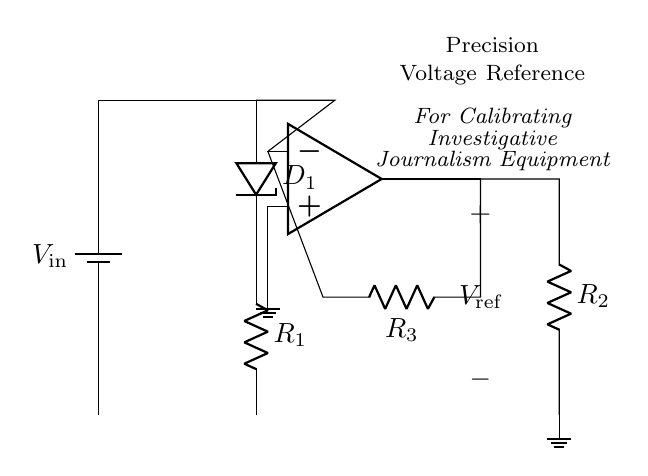What type of diode is used in this circuit? The circuit shows a Zener diode labeled as D1. Zener diodes are specifically used for voltage regulation.
Answer: Zener diode What is the value of the output voltage labeled as V_ref? The output voltage is the reference voltage defined in the circuit, typically determined by the configuration of the operational amplifier and the resistors. However, the circuit does not specify a numeric value for V_ref.
Answer: Not specified What is the purpose of the operational amplifier in this circuit? The operational amplifier is used to amplify the voltage from the Zener diode, providing a stable reference voltage output. Its role is critical for maintaining the desired precision in voltage reference applications.
Answer: To amplify What are the resistor labels in the feedback network? The feedback network has two resistors labeled R2 and R3. These resistors influence the feedback and gain of the operational amplifier, affecting the output voltage stability.
Answer: R2 and R3 What does the ground indicate in this circuit? The ground serves as a reference point for the circuit, indicating zero voltage. It is essential for establishing a common return path for the current. This means that all other voltages in the circuit are measured concerning this point.
Answer: Zero voltage What connections can be seen at the input of the operational amplifier? The input connections to the operational amplifier are from the Zener diode, and there is also a connection to ground at the non-inverting terminal. This setup indicates a feedback path involving the resistors and the diode.
Answer: Zener diode and ground 